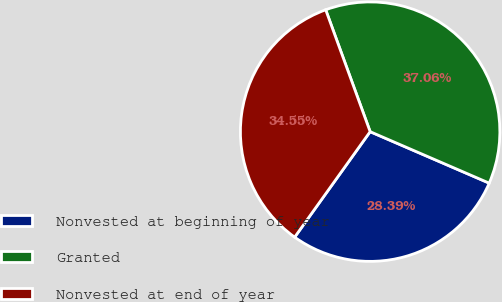Convert chart. <chart><loc_0><loc_0><loc_500><loc_500><pie_chart><fcel>Nonvested at beginning of year<fcel>Granted<fcel>Nonvested at end of year<nl><fcel>28.39%<fcel>37.06%<fcel>34.55%<nl></chart> 